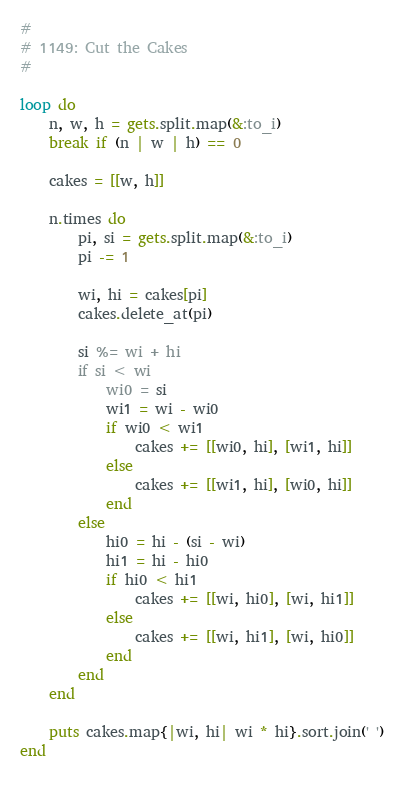Convert code to text. <code><loc_0><loc_0><loc_500><loc_500><_Ruby_>#
# 1149: Cut the Cakes
#

loop do
    n, w, h = gets.split.map(&:to_i)
    break if (n | w | h) == 0
    
    cakes = [[w, h]]
    
    n.times do
        pi, si = gets.split.map(&:to_i)
        pi -= 1
        
        wi, hi = cakes[pi]
        cakes.delete_at(pi)
        
        si %= wi + hi
        if si < wi 
            wi0 = si 
            wi1 = wi - wi0
            if wi0 < wi1
                cakes += [[wi0, hi], [wi1, hi]]
            else
                cakes += [[wi1, hi], [wi0, hi]]
            end
        else
            hi0 = hi - (si - wi)
            hi1 = hi - hi0
            if hi0 < hi1
                cakes += [[wi, hi0], [wi, hi1]]
            else
                cakes += [[wi, hi1], [wi, hi0]]
            end
        end
    end
    
    puts cakes.map{|wi, hi| wi * hi}.sort.join(' ')
end
    </code> 